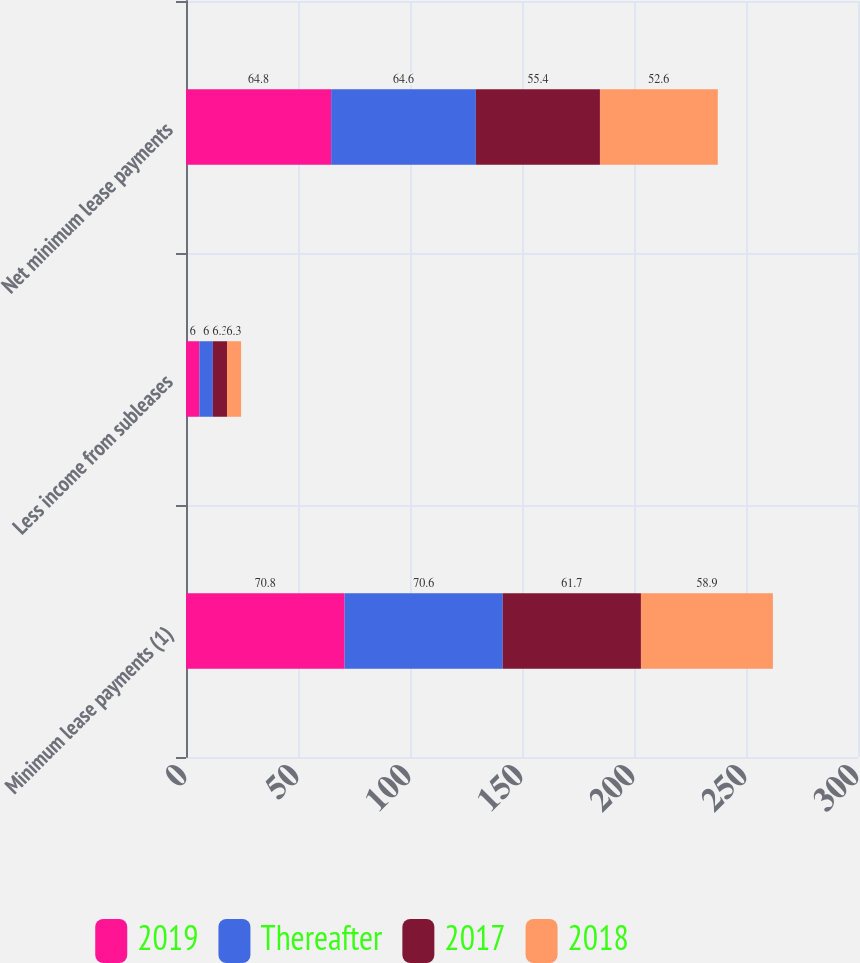Convert chart. <chart><loc_0><loc_0><loc_500><loc_500><stacked_bar_chart><ecel><fcel>Minimum lease payments (1)<fcel>Less income from subleases<fcel>Net minimum lease payments<nl><fcel>2019<fcel>70.8<fcel>6<fcel>64.8<nl><fcel>Thereafter<fcel>70.6<fcel>6<fcel>64.6<nl><fcel>2017<fcel>61.7<fcel>6.3<fcel>55.4<nl><fcel>2018<fcel>58.9<fcel>6.3<fcel>52.6<nl></chart> 